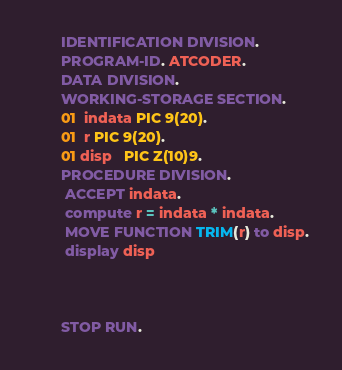Convert code to text. <code><loc_0><loc_0><loc_500><loc_500><_COBOL_>       IDENTIFICATION DIVISION.
       PROGRAM-ID. ATCODER.
       DATA DIVISION.
       WORKING-STORAGE SECTION.
       01  indata PIC 9(20).
       01  r PIC 9(20).
       01 disp   PIC Z(10)9.
       PROCEDURE DIVISION.
        ACCEPT indata.
        compute r = indata * indata.
        MOVE FUNCTION TRIM(r) to disp.
        display disp

        

       STOP RUN.
</code> 